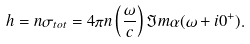<formula> <loc_0><loc_0><loc_500><loc_500>h = n \sigma _ { t o t } = 4 \pi n \left ( \frac { \omega } { c } \right ) { \Im } m \alpha ( \omega + i 0 ^ { + } ) .</formula> 